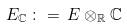<formula> <loc_0><loc_0><loc_500><loc_500>E _ { \mathbb { C } } \, \colon = \, E \otimes _ { \mathbb { R } } { \mathbb { C } }</formula> 